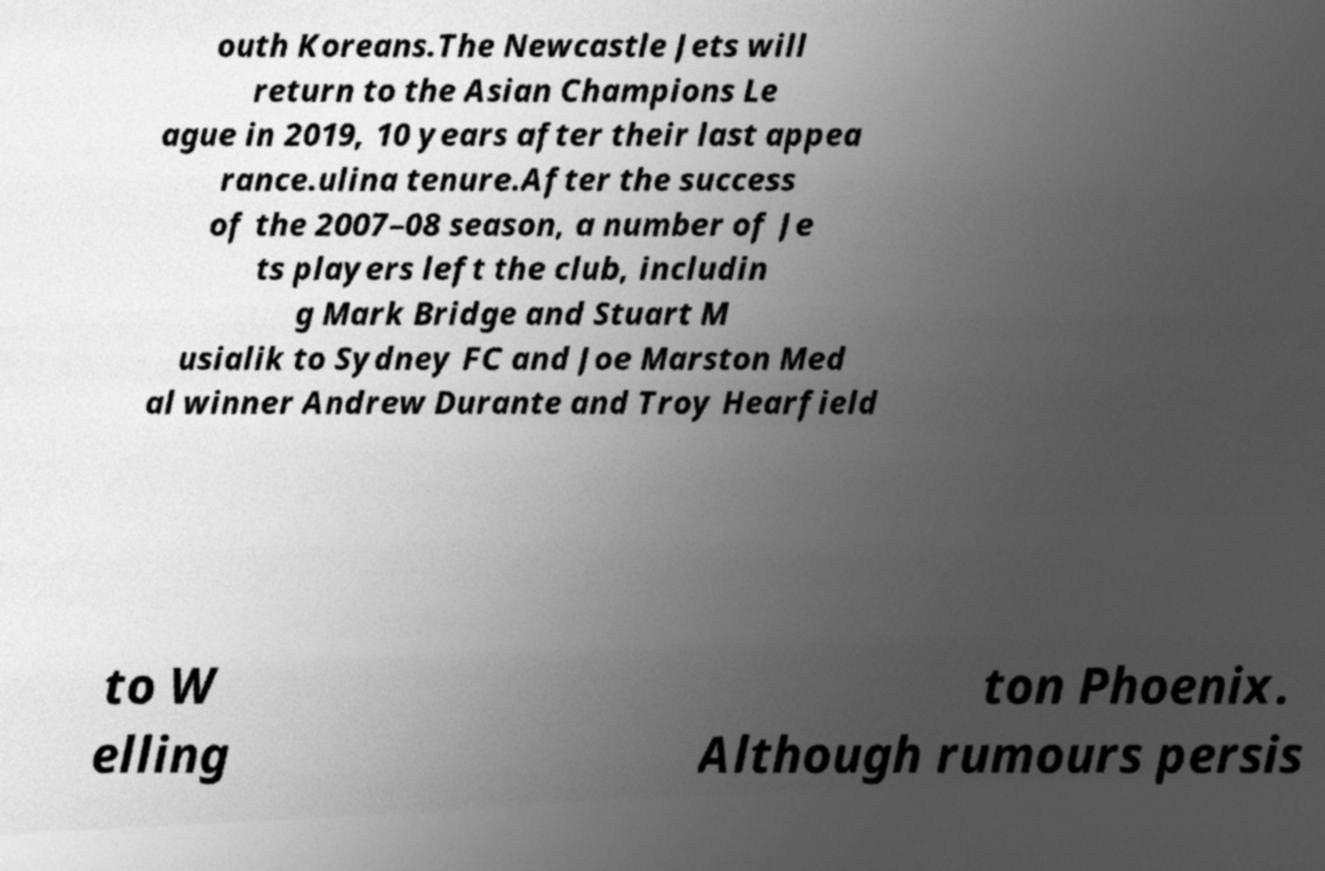I need the written content from this picture converted into text. Can you do that? outh Koreans.The Newcastle Jets will return to the Asian Champions Le ague in 2019, 10 years after their last appea rance.ulina tenure.After the success of the 2007–08 season, a number of Je ts players left the club, includin g Mark Bridge and Stuart M usialik to Sydney FC and Joe Marston Med al winner Andrew Durante and Troy Hearfield to W elling ton Phoenix. Although rumours persis 